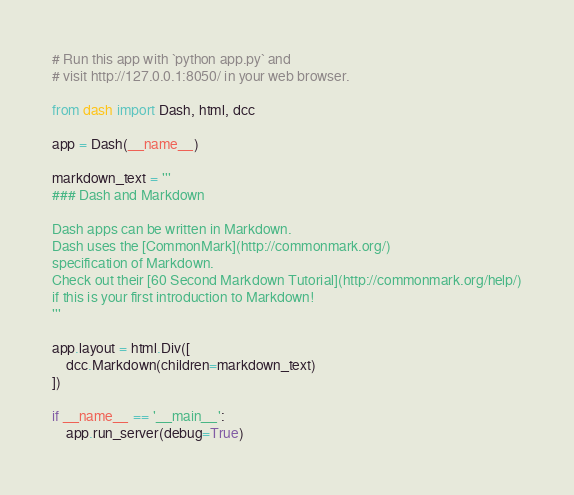<code> <loc_0><loc_0><loc_500><loc_500><_Python_># Run this app with `python app.py` and
# visit http://127.0.0.1:8050/ in your web browser.

from dash import Dash, html, dcc

app = Dash(__name__)

markdown_text = '''
### Dash and Markdown

Dash apps can be written in Markdown.
Dash uses the [CommonMark](http://commonmark.org/)
specification of Markdown.
Check out their [60 Second Markdown Tutorial](http://commonmark.org/help/)
if this is your first introduction to Markdown!
'''

app.layout = html.Div([
    dcc.Markdown(children=markdown_text)
])

if __name__ == '__main__':
    app.run_server(debug=True)
</code> 